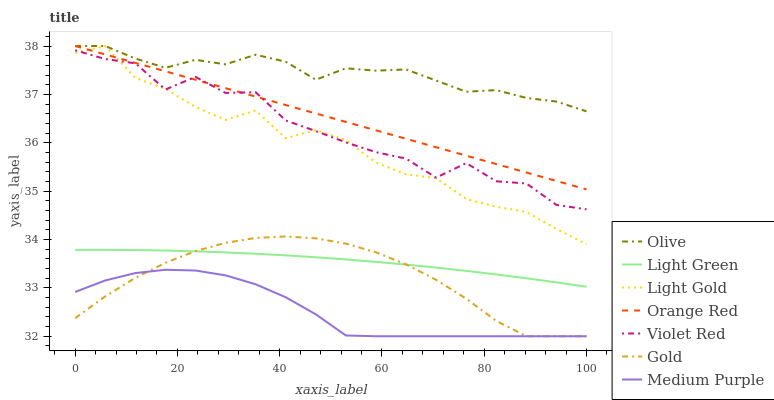Does Medium Purple have the minimum area under the curve?
Answer yes or no. Yes. Does Gold have the minimum area under the curve?
Answer yes or no. No. Does Gold have the maximum area under the curve?
Answer yes or no. No. Is Orange Red the smoothest?
Answer yes or no. Yes. Is Violet Red the roughest?
Answer yes or no. Yes. Is Gold the smoothest?
Answer yes or no. No. Is Gold the roughest?
Answer yes or no. No. Does Light Green have the lowest value?
Answer yes or no. No. Does Gold have the highest value?
Answer yes or no. No. Is Medium Purple less than Violet Red?
Answer yes or no. Yes. Is Light Green greater than Medium Purple?
Answer yes or no. Yes. Does Medium Purple intersect Violet Red?
Answer yes or no. No. 